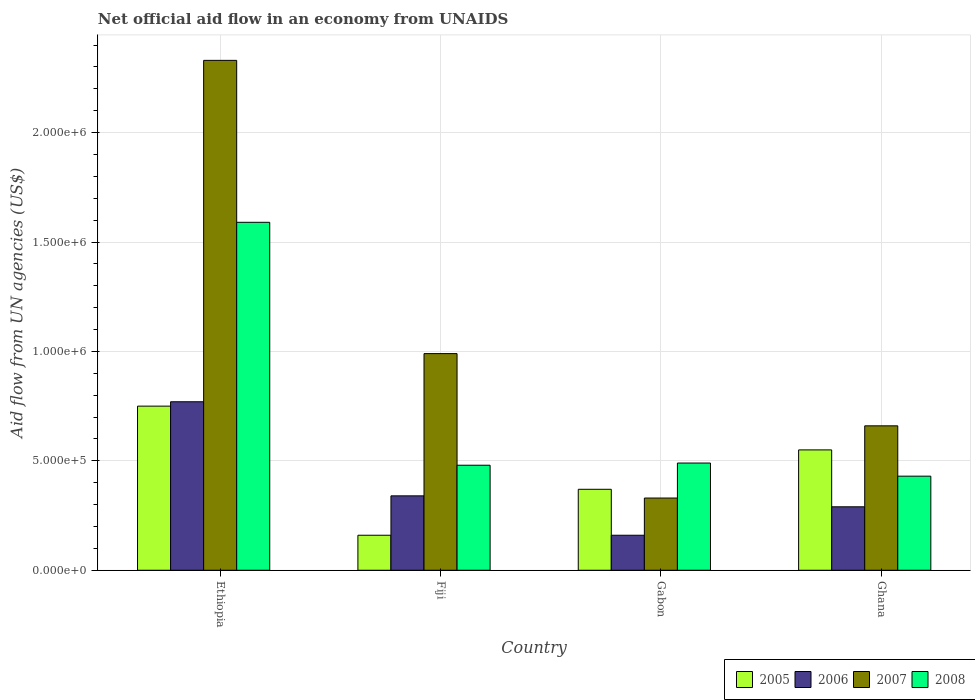How many groups of bars are there?
Keep it short and to the point. 4. Are the number of bars per tick equal to the number of legend labels?
Give a very brief answer. Yes. Are the number of bars on each tick of the X-axis equal?
Make the answer very short. Yes. What is the label of the 2nd group of bars from the left?
Your answer should be very brief. Fiji. In how many cases, is the number of bars for a given country not equal to the number of legend labels?
Ensure brevity in your answer.  0. What is the net official aid flow in 2008 in Ethiopia?
Offer a very short reply. 1.59e+06. Across all countries, what is the maximum net official aid flow in 2005?
Your answer should be very brief. 7.50e+05. In which country was the net official aid flow in 2008 maximum?
Keep it short and to the point. Ethiopia. What is the total net official aid flow in 2008 in the graph?
Ensure brevity in your answer.  2.99e+06. What is the difference between the net official aid flow in 2008 in Gabon and the net official aid flow in 2007 in Fiji?
Keep it short and to the point. -5.00e+05. What is the average net official aid flow in 2005 per country?
Provide a short and direct response. 4.58e+05. What is the difference between the net official aid flow of/in 2007 and net official aid flow of/in 2006 in Fiji?
Give a very brief answer. 6.50e+05. What is the ratio of the net official aid flow in 2005 in Ethiopia to that in Gabon?
Offer a terse response. 2.03. Is the net official aid flow in 2007 in Gabon less than that in Ghana?
Provide a short and direct response. Yes. What is the difference between the highest and the second highest net official aid flow in 2007?
Give a very brief answer. 1.34e+06. What is the difference between the highest and the lowest net official aid flow in 2007?
Your answer should be compact. 2.00e+06. In how many countries, is the net official aid flow in 2007 greater than the average net official aid flow in 2007 taken over all countries?
Give a very brief answer. 1. Is the sum of the net official aid flow in 2005 in Ethiopia and Gabon greater than the maximum net official aid flow in 2006 across all countries?
Your answer should be compact. Yes. Is it the case that in every country, the sum of the net official aid flow in 2007 and net official aid flow in 2005 is greater than the sum of net official aid flow in 2006 and net official aid flow in 2008?
Provide a short and direct response. Yes. What does the 1st bar from the left in Ghana represents?
Make the answer very short. 2005. What does the 3rd bar from the right in Gabon represents?
Offer a very short reply. 2006. Are the values on the major ticks of Y-axis written in scientific E-notation?
Keep it short and to the point. Yes. How many legend labels are there?
Your answer should be compact. 4. How are the legend labels stacked?
Provide a succinct answer. Horizontal. What is the title of the graph?
Ensure brevity in your answer.  Net official aid flow in an economy from UNAIDS. Does "2009" appear as one of the legend labels in the graph?
Offer a terse response. No. What is the label or title of the Y-axis?
Give a very brief answer. Aid flow from UN agencies (US$). What is the Aid flow from UN agencies (US$) in 2005 in Ethiopia?
Keep it short and to the point. 7.50e+05. What is the Aid flow from UN agencies (US$) in 2006 in Ethiopia?
Ensure brevity in your answer.  7.70e+05. What is the Aid flow from UN agencies (US$) of 2007 in Ethiopia?
Give a very brief answer. 2.33e+06. What is the Aid flow from UN agencies (US$) in 2008 in Ethiopia?
Provide a succinct answer. 1.59e+06. What is the Aid flow from UN agencies (US$) in 2005 in Fiji?
Keep it short and to the point. 1.60e+05. What is the Aid flow from UN agencies (US$) in 2007 in Fiji?
Your answer should be compact. 9.90e+05. What is the Aid flow from UN agencies (US$) of 2008 in Fiji?
Keep it short and to the point. 4.80e+05. What is the Aid flow from UN agencies (US$) of 2006 in Gabon?
Provide a short and direct response. 1.60e+05. What is the Aid flow from UN agencies (US$) of 2007 in Gabon?
Give a very brief answer. 3.30e+05. What is the Aid flow from UN agencies (US$) of 2005 in Ghana?
Ensure brevity in your answer.  5.50e+05. What is the Aid flow from UN agencies (US$) of 2007 in Ghana?
Your answer should be very brief. 6.60e+05. What is the Aid flow from UN agencies (US$) of 2008 in Ghana?
Offer a very short reply. 4.30e+05. Across all countries, what is the maximum Aid flow from UN agencies (US$) of 2005?
Make the answer very short. 7.50e+05. Across all countries, what is the maximum Aid flow from UN agencies (US$) of 2006?
Ensure brevity in your answer.  7.70e+05. Across all countries, what is the maximum Aid flow from UN agencies (US$) in 2007?
Your answer should be very brief. 2.33e+06. Across all countries, what is the maximum Aid flow from UN agencies (US$) of 2008?
Give a very brief answer. 1.59e+06. Across all countries, what is the minimum Aid flow from UN agencies (US$) of 2006?
Provide a short and direct response. 1.60e+05. Across all countries, what is the minimum Aid flow from UN agencies (US$) in 2007?
Provide a short and direct response. 3.30e+05. What is the total Aid flow from UN agencies (US$) in 2005 in the graph?
Provide a short and direct response. 1.83e+06. What is the total Aid flow from UN agencies (US$) in 2006 in the graph?
Give a very brief answer. 1.56e+06. What is the total Aid flow from UN agencies (US$) in 2007 in the graph?
Your answer should be compact. 4.31e+06. What is the total Aid flow from UN agencies (US$) of 2008 in the graph?
Your response must be concise. 2.99e+06. What is the difference between the Aid flow from UN agencies (US$) in 2005 in Ethiopia and that in Fiji?
Your answer should be compact. 5.90e+05. What is the difference between the Aid flow from UN agencies (US$) of 2007 in Ethiopia and that in Fiji?
Your response must be concise. 1.34e+06. What is the difference between the Aid flow from UN agencies (US$) of 2008 in Ethiopia and that in Fiji?
Your answer should be very brief. 1.11e+06. What is the difference between the Aid flow from UN agencies (US$) in 2006 in Ethiopia and that in Gabon?
Keep it short and to the point. 6.10e+05. What is the difference between the Aid flow from UN agencies (US$) of 2007 in Ethiopia and that in Gabon?
Your answer should be compact. 2.00e+06. What is the difference between the Aid flow from UN agencies (US$) of 2008 in Ethiopia and that in Gabon?
Give a very brief answer. 1.10e+06. What is the difference between the Aid flow from UN agencies (US$) of 2007 in Ethiopia and that in Ghana?
Provide a short and direct response. 1.67e+06. What is the difference between the Aid flow from UN agencies (US$) in 2008 in Ethiopia and that in Ghana?
Keep it short and to the point. 1.16e+06. What is the difference between the Aid flow from UN agencies (US$) of 2005 in Fiji and that in Gabon?
Give a very brief answer. -2.10e+05. What is the difference between the Aid flow from UN agencies (US$) in 2006 in Fiji and that in Gabon?
Your answer should be compact. 1.80e+05. What is the difference between the Aid flow from UN agencies (US$) in 2007 in Fiji and that in Gabon?
Your answer should be very brief. 6.60e+05. What is the difference between the Aid flow from UN agencies (US$) of 2008 in Fiji and that in Gabon?
Give a very brief answer. -10000. What is the difference between the Aid flow from UN agencies (US$) in 2005 in Fiji and that in Ghana?
Your answer should be compact. -3.90e+05. What is the difference between the Aid flow from UN agencies (US$) of 2007 in Fiji and that in Ghana?
Provide a succinct answer. 3.30e+05. What is the difference between the Aid flow from UN agencies (US$) of 2008 in Fiji and that in Ghana?
Give a very brief answer. 5.00e+04. What is the difference between the Aid flow from UN agencies (US$) of 2006 in Gabon and that in Ghana?
Make the answer very short. -1.30e+05. What is the difference between the Aid flow from UN agencies (US$) in 2007 in Gabon and that in Ghana?
Offer a terse response. -3.30e+05. What is the difference between the Aid flow from UN agencies (US$) in 2008 in Gabon and that in Ghana?
Ensure brevity in your answer.  6.00e+04. What is the difference between the Aid flow from UN agencies (US$) of 2005 in Ethiopia and the Aid flow from UN agencies (US$) of 2006 in Fiji?
Make the answer very short. 4.10e+05. What is the difference between the Aid flow from UN agencies (US$) in 2007 in Ethiopia and the Aid flow from UN agencies (US$) in 2008 in Fiji?
Your response must be concise. 1.85e+06. What is the difference between the Aid flow from UN agencies (US$) in 2005 in Ethiopia and the Aid flow from UN agencies (US$) in 2006 in Gabon?
Your answer should be very brief. 5.90e+05. What is the difference between the Aid flow from UN agencies (US$) in 2006 in Ethiopia and the Aid flow from UN agencies (US$) in 2008 in Gabon?
Offer a very short reply. 2.80e+05. What is the difference between the Aid flow from UN agencies (US$) in 2007 in Ethiopia and the Aid flow from UN agencies (US$) in 2008 in Gabon?
Offer a very short reply. 1.84e+06. What is the difference between the Aid flow from UN agencies (US$) of 2005 in Ethiopia and the Aid flow from UN agencies (US$) of 2007 in Ghana?
Give a very brief answer. 9.00e+04. What is the difference between the Aid flow from UN agencies (US$) in 2005 in Ethiopia and the Aid flow from UN agencies (US$) in 2008 in Ghana?
Your answer should be compact. 3.20e+05. What is the difference between the Aid flow from UN agencies (US$) of 2006 in Ethiopia and the Aid flow from UN agencies (US$) of 2008 in Ghana?
Keep it short and to the point. 3.40e+05. What is the difference between the Aid flow from UN agencies (US$) of 2007 in Ethiopia and the Aid flow from UN agencies (US$) of 2008 in Ghana?
Offer a very short reply. 1.90e+06. What is the difference between the Aid flow from UN agencies (US$) of 2005 in Fiji and the Aid flow from UN agencies (US$) of 2006 in Gabon?
Make the answer very short. 0. What is the difference between the Aid flow from UN agencies (US$) of 2005 in Fiji and the Aid flow from UN agencies (US$) of 2008 in Gabon?
Your response must be concise. -3.30e+05. What is the difference between the Aid flow from UN agencies (US$) in 2006 in Fiji and the Aid flow from UN agencies (US$) in 2007 in Gabon?
Your answer should be compact. 10000. What is the difference between the Aid flow from UN agencies (US$) of 2006 in Fiji and the Aid flow from UN agencies (US$) of 2008 in Gabon?
Provide a short and direct response. -1.50e+05. What is the difference between the Aid flow from UN agencies (US$) in 2005 in Fiji and the Aid flow from UN agencies (US$) in 2006 in Ghana?
Provide a succinct answer. -1.30e+05. What is the difference between the Aid flow from UN agencies (US$) of 2005 in Fiji and the Aid flow from UN agencies (US$) of 2007 in Ghana?
Your answer should be very brief. -5.00e+05. What is the difference between the Aid flow from UN agencies (US$) in 2005 in Fiji and the Aid flow from UN agencies (US$) in 2008 in Ghana?
Make the answer very short. -2.70e+05. What is the difference between the Aid flow from UN agencies (US$) of 2006 in Fiji and the Aid flow from UN agencies (US$) of 2007 in Ghana?
Make the answer very short. -3.20e+05. What is the difference between the Aid flow from UN agencies (US$) of 2007 in Fiji and the Aid flow from UN agencies (US$) of 2008 in Ghana?
Keep it short and to the point. 5.60e+05. What is the difference between the Aid flow from UN agencies (US$) of 2005 in Gabon and the Aid flow from UN agencies (US$) of 2006 in Ghana?
Offer a very short reply. 8.00e+04. What is the difference between the Aid flow from UN agencies (US$) of 2005 in Gabon and the Aid flow from UN agencies (US$) of 2007 in Ghana?
Make the answer very short. -2.90e+05. What is the difference between the Aid flow from UN agencies (US$) of 2005 in Gabon and the Aid flow from UN agencies (US$) of 2008 in Ghana?
Give a very brief answer. -6.00e+04. What is the difference between the Aid flow from UN agencies (US$) in 2006 in Gabon and the Aid flow from UN agencies (US$) in 2007 in Ghana?
Your answer should be very brief. -5.00e+05. What is the average Aid flow from UN agencies (US$) in 2005 per country?
Make the answer very short. 4.58e+05. What is the average Aid flow from UN agencies (US$) in 2007 per country?
Give a very brief answer. 1.08e+06. What is the average Aid flow from UN agencies (US$) in 2008 per country?
Provide a short and direct response. 7.48e+05. What is the difference between the Aid flow from UN agencies (US$) in 2005 and Aid flow from UN agencies (US$) in 2007 in Ethiopia?
Offer a very short reply. -1.58e+06. What is the difference between the Aid flow from UN agencies (US$) in 2005 and Aid flow from UN agencies (US$) in 2008 in Ethiopia?
Provide a short and direct response. -8.40e+05. What is the difference between the Aid flow from UN agencies (US$) of 2006 and Aid flow from UN agencies (US$) of 2007 in Ethiopia?
Your response must be concise. -1.56e+06. What is the difference between the Aid flow from UN agencies (US$) in 2006 and Aid flow from UN agencies (US$) in 2008 in Ethiopia?
Your answer should be compact. -8.20e+05. What is the difference between the Aid flow from UN agencies (US$) of 2007 and Aid flow from UN agencies (US$) of 2008 in Ethiopia?
Give a very brief answer. 7.40e+05. What is the difference between the Aid flow from UN agencies (US$) in 2005 and Aid flow from UN agencies (US$) in 2007 in Fiji?
Ensure brevity in your answer.  -8.30e+05. What is the difference between the Aid flow from UN agencies (US$) of 2005 and Aid flow from UN agencies (US$) of 2008 in Fiji?
Your response must be concise. -3.20e+05. What is the difference between the Aid flow from UN agencies (US$) of 2006 and Aid flow from UN agencies (US$) of 2007 in Fiji?
Ensure brevity in your answer.  -6.50e+05. What is the difference between the Aid flow from UN agencies (US$) in 2006 and Aid flow from UN agencies (US$) in 2008 in Fiji?
Provide a short and direct response. -1.40e+05. What is the difference between the Aid flow from UN agencies (US$) in 2007 and Aid flow from UN agencies (US$) in 2008 in Fiji?
Your answer should be compact. 5.10e+05. What is the difference between the Aid flow from UN agencies (US$) of 2005 and Aid flow from UN agencies (US$) of 2006 in Gabon?
Your response must be concise. 2.10e+05. What is the difference between the Aid flow from UN agencies (US$) in 2006 and Aid flow from UN agencies (US$) in 2007 in Gabon?
Provide a succinct answer. -1.70e+05. What is the difference between the Aid flow from UN agencies (US$) of 2006 and Aid flow from UN agencies (US$) of 2008 in Gabon?
Your answer should be very brief. -3.30e+05. What is the difference between the Aid flow from UN agencies (US$) in 2007 and Aid flow from UN agencies (US$) in 2008 in Gabon?
Offer a terse response. -1.60e+05. What is the difference between the Aid flow from UN agencies (US$) of 2005 and Aid flow from UN agencies (US$) of 2008 in Ghana?
Give a very brief answer. 1.20e+05. What is the difference between the Aid flow from UN agencies (US$) of 2006 and Aid flow from UN agencies (US$) of 2007 in Ghana?
Offer a very short reply. -3.70e+05. What is the ratio of the Aid flow from UN agencies (US$) of 2005 in Ethiopia to that in Fiji?
Your response must be concise. 4.69. What is the ratio of the Aid flow from UN agencies (US$) in 2006 in Ethiopia to that in Fiji?
Keep it short and to the point. 2.26. What is the ratio of the Aid flow from UN agencies (US$) in 2007 in Ethiopia to that in Fiji?
Keep it short and to the point. 2.35. What is the ratio of the Aid flow from UN agencies (US$) of 2008 in Ethiopia to that in Fiji?
Your answer should be very brief. 3.31. What is the ratio of the Aid flow from UN agencies (US$) of 2005 in Ethiopia to that in Gabon?
Your answer should be very brief. 2.03. What is the ratio of the Aid flow from UN agencies (US$) of 2006 in Ethiopia to that in Gabon?
Offer a terse response. 4.81. What is the ratio of the Aid flow from UN agencies (US$) of 2007 in Ethiopia to that in Gabon?
Make the answer very short. 7.06. What is the ratio of the Aid flow from UN agencies (US$) in 2008 in Ethiopia to that in Gabon?
Your answer should be compact. 3.24. What is the ratio of the Aid flow from UN agencies (US$) of 2005 in Ethiopia to that in Ghana?
Give a very brief answer. 1.36. What is the ratio of the Aid flow from UN agencies (US$) of 2006 in Ethiopia to that in Ghana?
Offer a very short reply. 2.66. What is the ratio of the Aid flow from UN agencies (US$) of 2007 in Ethiopia to that in Ghana?
Your answer should be compact. 3.53. What is the ratio of the Aid flow from UN agencies (US$) of 2008 in Ethiopia to that in Ghana?
Give a very brief answer. 3.7. What is the ratio of the Aid flow from UN agencies (US$) of 2005 in Fiji to that in Gabon?
Make the answer very short. 0.43. What is the ratio of the Aid flow from UN agencies (US$) in 2006 in Fiji to that in Gabon?
Your answer should be very brief. 2.12. What is the ratio of the Aid flow from UN agencies (US$) in 2007 in Fiji to that in Gabon?
Make the answer very short. 3. What is the ratio of the Aid flow from UN agencies (US$) in 2008 in Fiji to that in Gabon?
Give a very brief answer. 0.98. What is the ratio of the Aid flow from UN agencies (US$) of 2005 in Fiji to that in Ghana?
Ensure brevity in your answer.  0.29. What is the ratio of the Aid flow from UN agencies (US$) of 2006 in Fiji to that in Ghana?
Provide a short and direct response. 1.17. What is the ratio of the Aid flow from UN agencies (US$) in 2007 in Fiji to that in Ghana?
Your answer should be very brief. 1.5. What is the ratio of the Aid flow from UN agencies (US$) of 2008 in Fiji to that in Ghana?
Offer a very short reply. 1.12. What is the ratio of the Aid flow from UN agencies (US$) of 2005 in Gabon to that in Ghana?
Provide a short and direct response. 0.67. What is the ratio of the Aid flow from UN agencies (US$) in 2006 in Gabon to that in Ghana?
Your answer should be compact. 0.55. What is the ratio of the Aid flow from UN agencies (US$) in 2008 in Gabon to that in Ghana?
Your response must be concise. 1.14. What is the difference between the highest and the second highest Aid flow from UN agencies (US$) in 2007?
Your answer should be compact. 1.34e+06. What is the difference between the highest and the second highest Aid flow from UN agencies (US$) of 2008?
Offer a terse response. 1.10e+06. What is the difference between the highest and the lowest Aid flow from UN agencies (US$) in 2005?
Offer a very short reply. 5.90e+05. What is the difference between the highest and the lowest Aid flow from UN agencies (US$) in 2006?
Offer a very short reply. 6.10e+05. What is the difference between the highest and the lowest Aid flow from UN agencies (US$) of 2007?
Your answer should be compact. 2.00e+06. What is the difference between the highest and the lowest Aid flow from UN agencies (US$) of 2008?
Offer a terse response. 1.16e+06. 